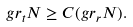<formula> <loc_0><loc_0><loc_500><loc_500>g r _ { t } N \geq C ( g r _ { r } N ) .</formula> 